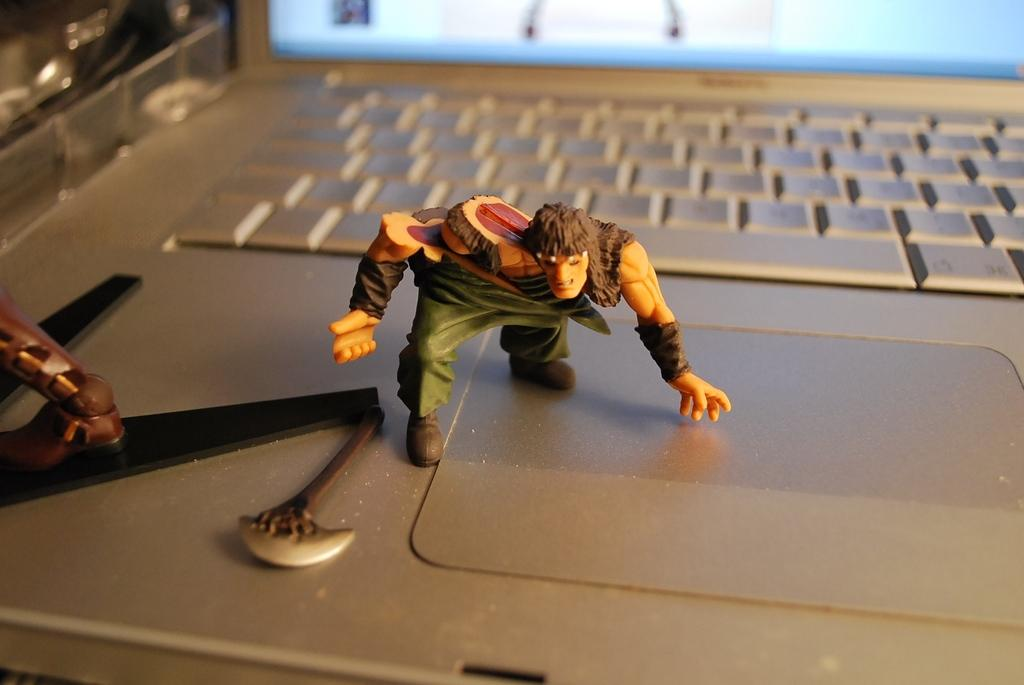What electronic device is visible in the image? There is a laptop in the image. What is placed on top of the laptop? The laptop has toys on it. Can you describe the composition of the image? There are objects truncated towards the left of the image. How does the laptop spread jam on the toys in the image? The laptop does not spread jam on the toys in the image; there is no jam present. 